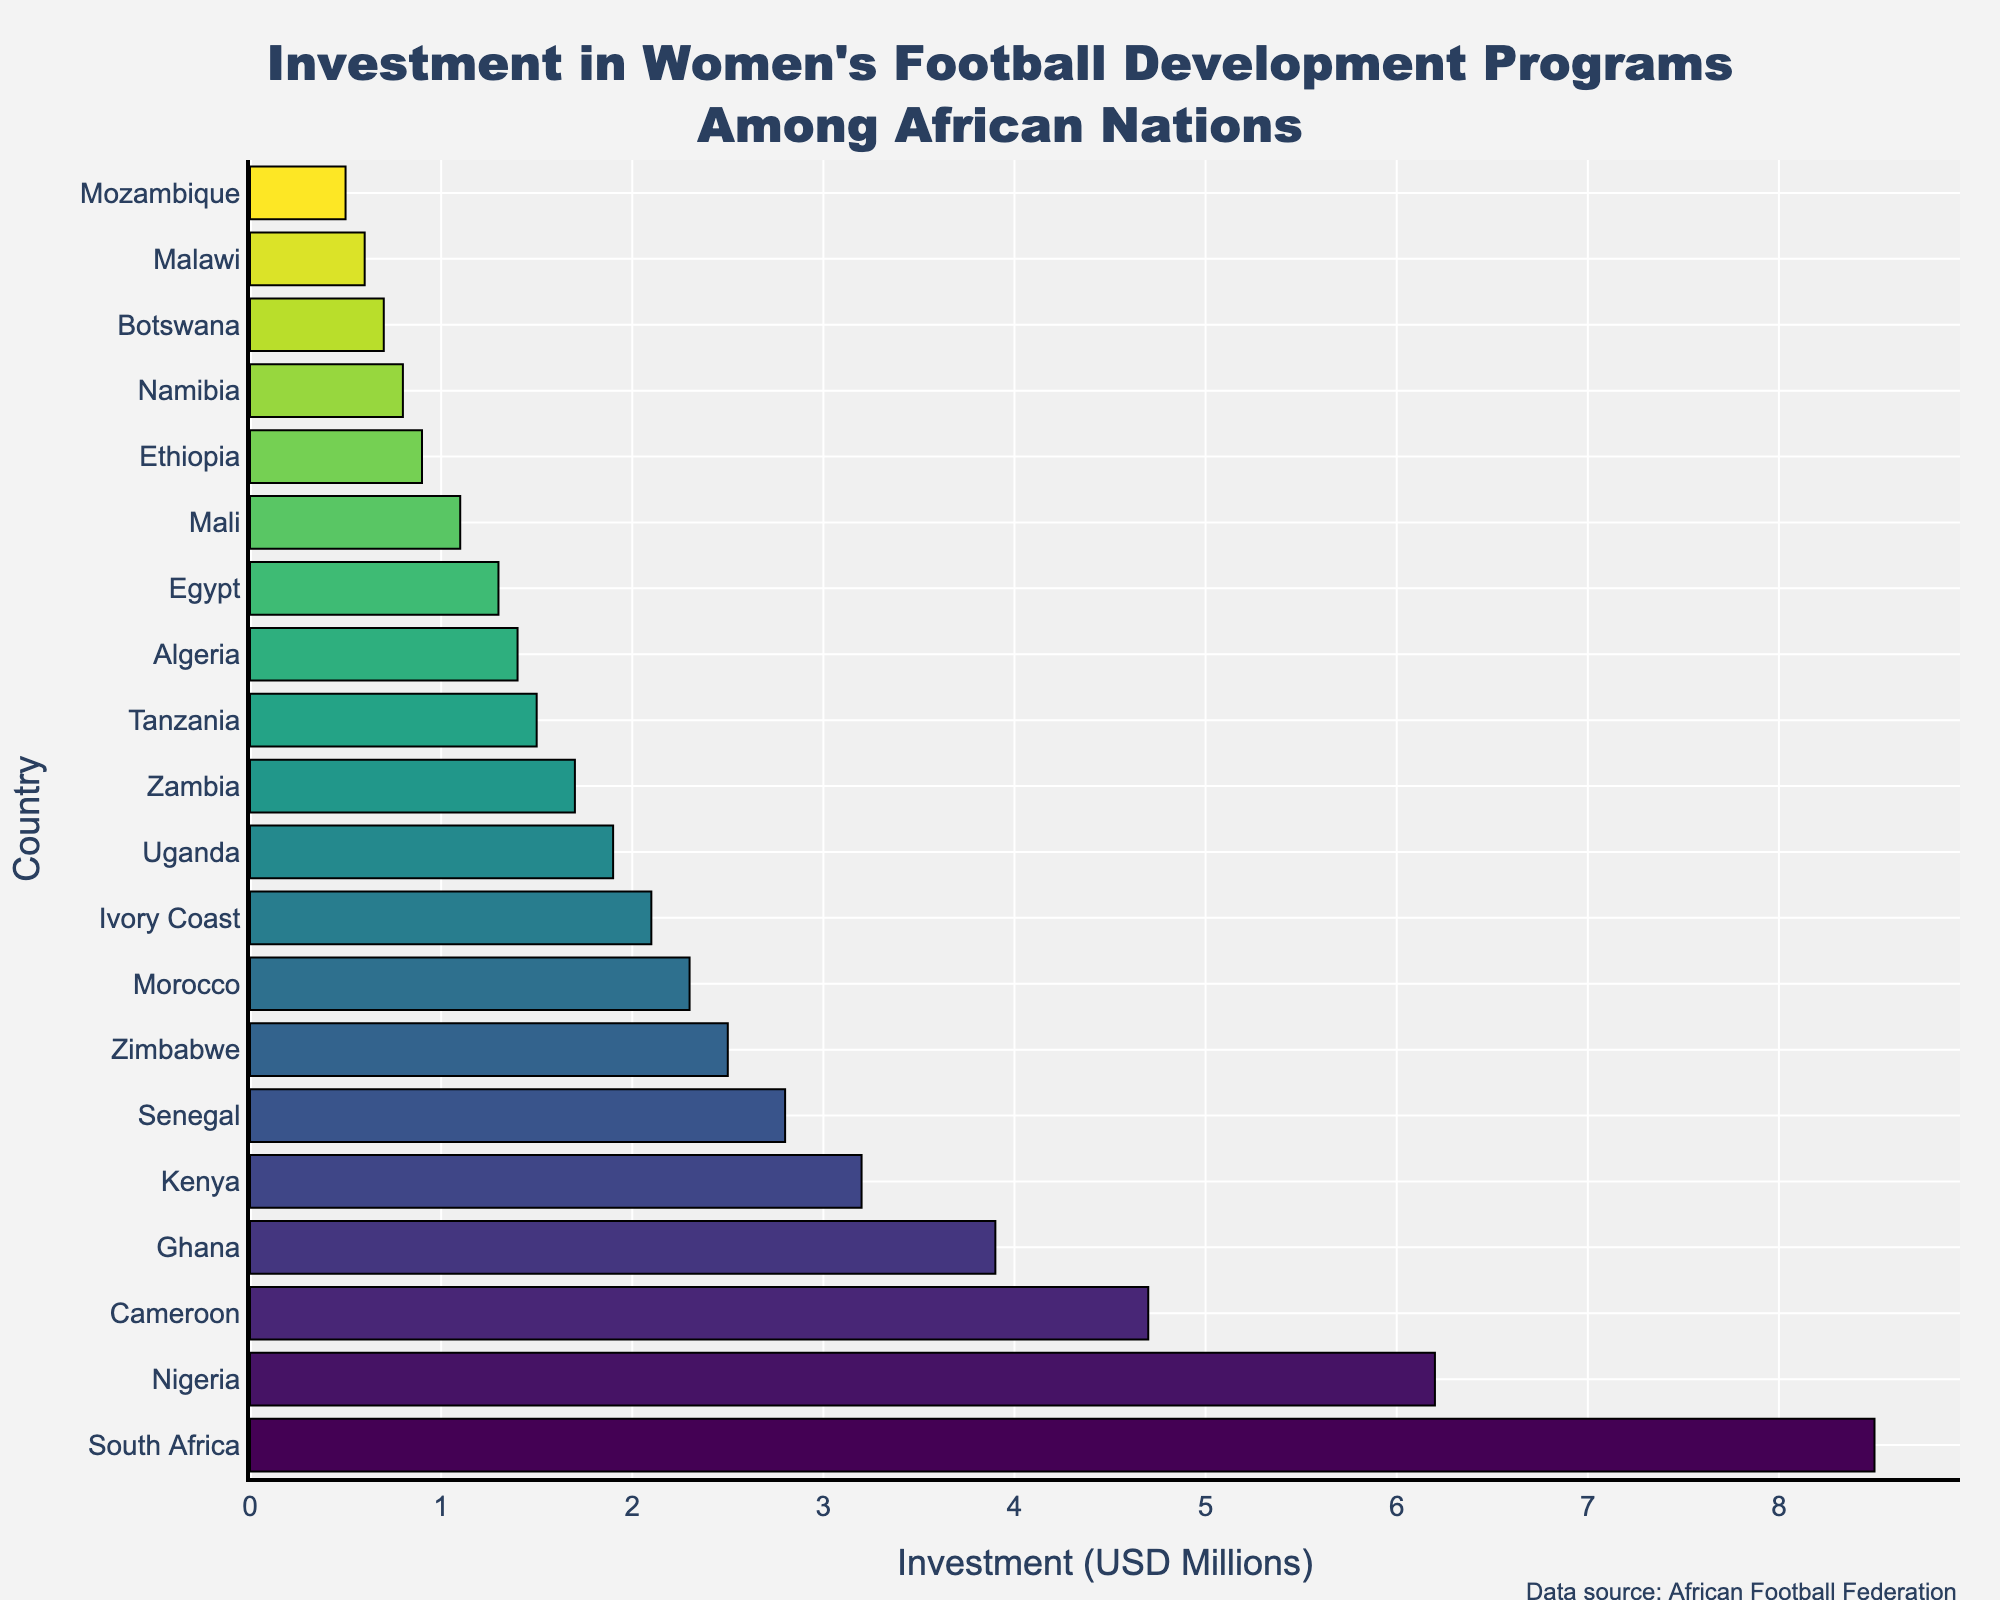Which country has the highest investment in women's football development programs? The bar chart shows investment amounts for different African countries. The tallest bar represents South Africa with an investment of 8.5 million USD.
Answer: South Africa What is the total investment for Nigeria and Ghana? Nigeria has an investment of 6.2 million USD and Ghana has an investment of 3.9 million USD. Adding these together, 6.2 + 3.9 = 10.1 million USD.
Answer: 10.1 million USD Which country has a higher investment, Kenya or Zimbabwe? The bar for Kenya shows an investment of 3.2 million USD while the bar for Zimbabwe shows an investment of 2.5 million USD. Kenya has a higher investment.
Answer: Kenya What is the difference in investment between Cameroon and Senegal? Cameroon has an investment of 4.7 million USD and Senegal has an investment of 2.8 million USD. The difference is 4.7 - 2.8 = 1.9 million USD.
Answer: 1.9 million USD How many countries have an investment of at least 2 million USD? Count the bars in the chart that reach or exceed the 2 million USD mark: South Africa, Nigeria, Cameroon, Ghana, Kenya, Senegal, Zimbabwe, Morocco, and Ivory Coast. There are 9 countries in total.
Answer: 9 Which countries have the same range of investment colors? The colors of the bars represent different ranges but similar color bands represent similar investment levels. Uganda and Zambia, for example, have closely related colors indicating similar investments (1.9 and 1.7 million USD, respectively).
Answer: Uganda, Zambia Which country has the lowest investment in women's football development programs? The shortest bar represents Mozambique with an investment of 0.5 million USD.
Answer: Mozambique What is the average investment among the top four countries? The top four countries are South Africa (8.5 million), Nigeria (6.2 million), Cameroon (4.7 million), and Ghana (3.9 million). The average is calculated as (8.5 + 6.2 + 4.7 + 3.9) / 4 = 23.3 / 4 = 5.825 million USD.
Answer: 5.825 million USD Is the investment in Morocco higher than in Ivory Coast? The bar for Morocco shows 2.3 million USD, while the bar for Ivory Coast shows 2.1 million USD. Morocco has a higher investment.
Answer: Morocco 